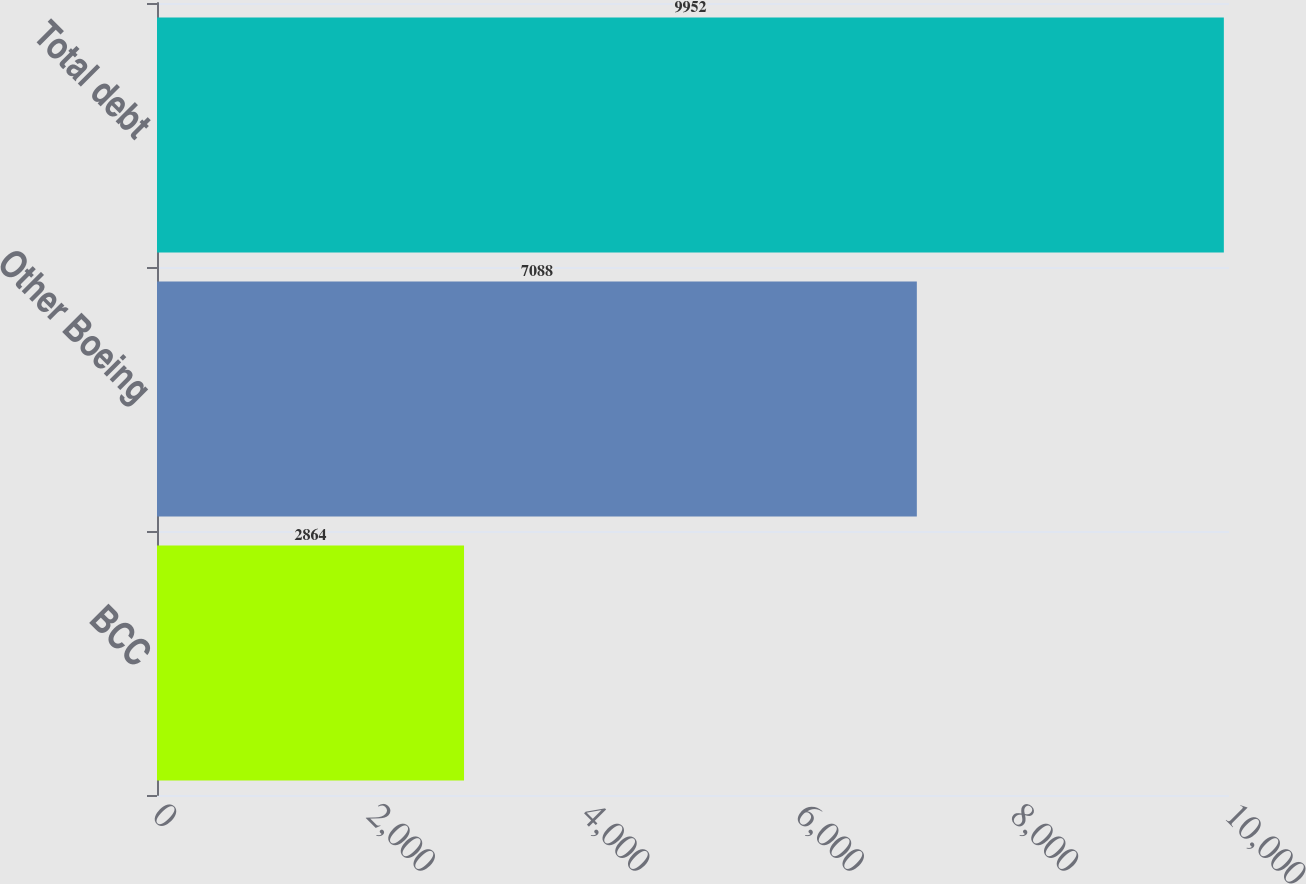Convert chart. <chart><loc_0><loc_0><loc_500><loc_500><bar_chart><fcel>BCC<fcel>Other Boeing<fcel>Total debt<nl><fcel>2864<fcel>7088<fcel>9952<nl></chart> 